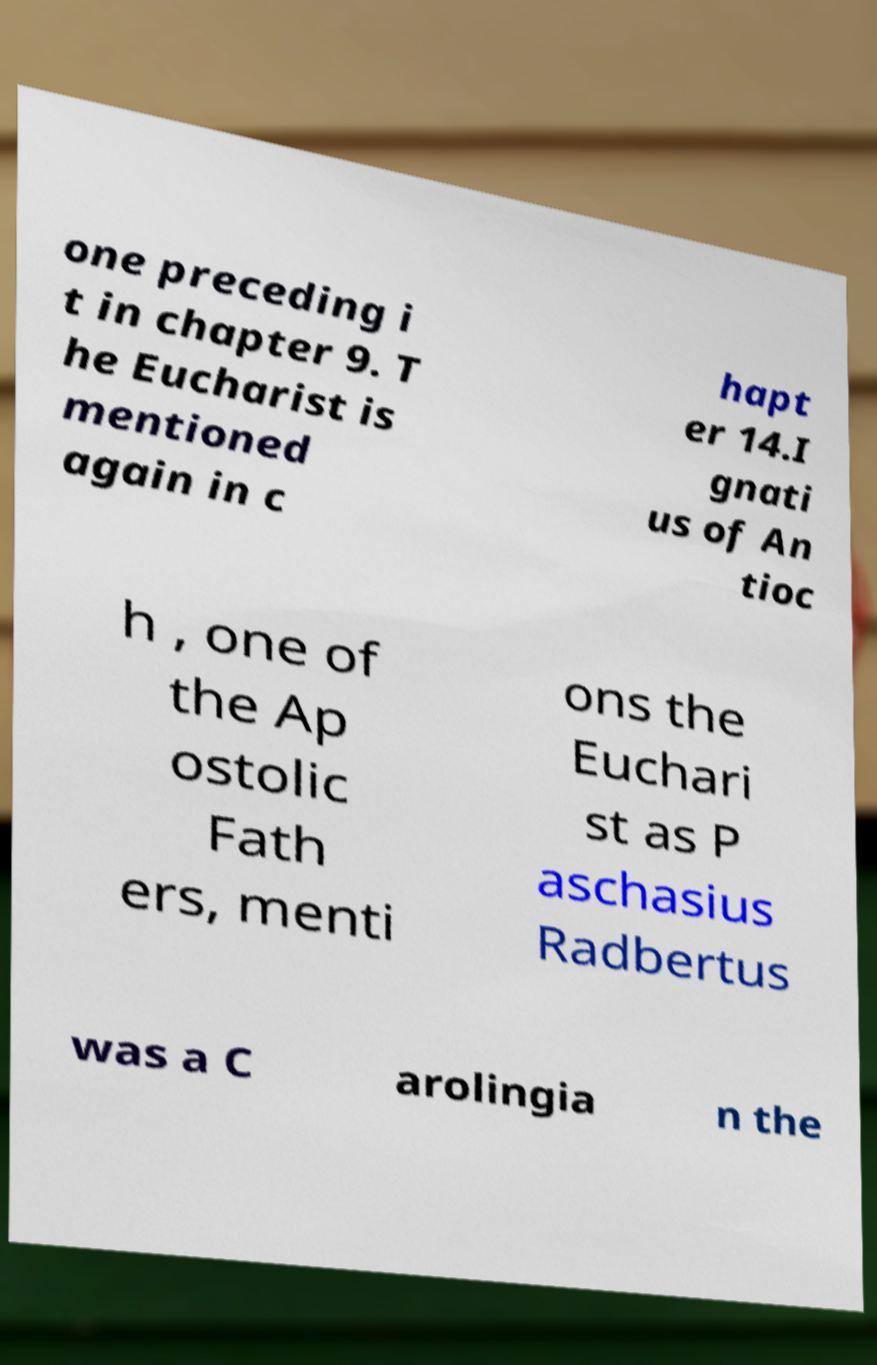What messages or text are displayed in this image? I need them in a readable, typed format. one preceding i t in chapter 9. T he Eucharist is mentioned again in c hapt er 14.I gnati us of An tioc h , one of the Ap ostolic Fath ers, menti ons the Euchari st as P aschasius Radbertus was a C arolingia n the 